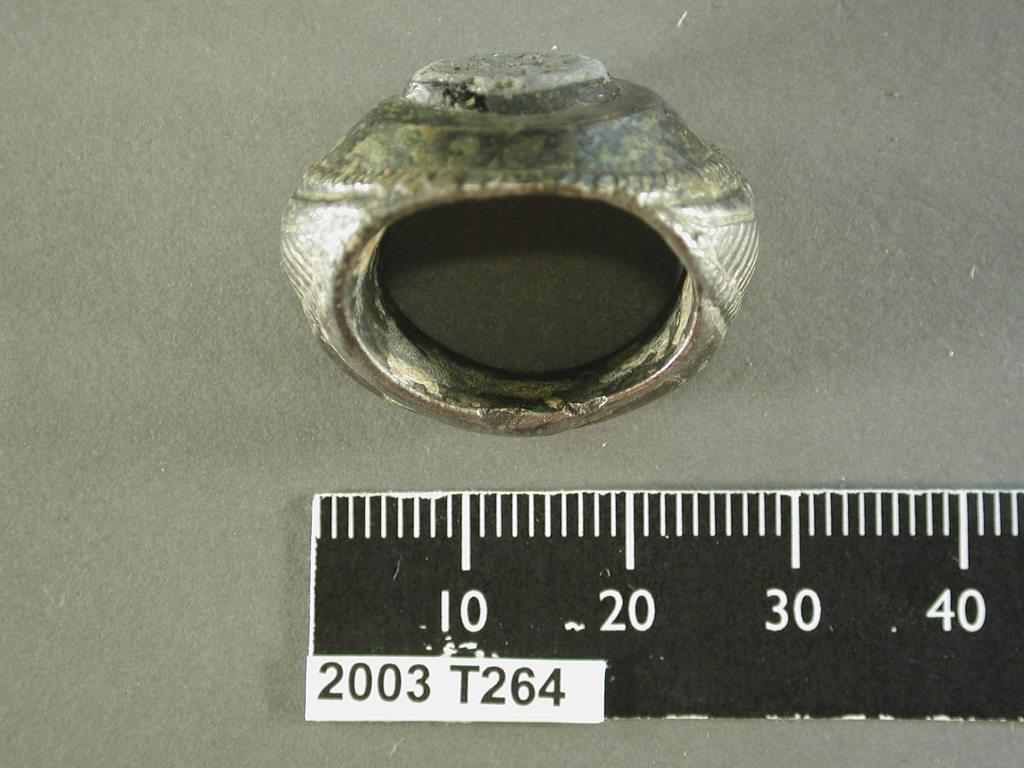<image>
Write a terse but informative summary of the picture. An old metal ring measures approximately 30 centimeters. 